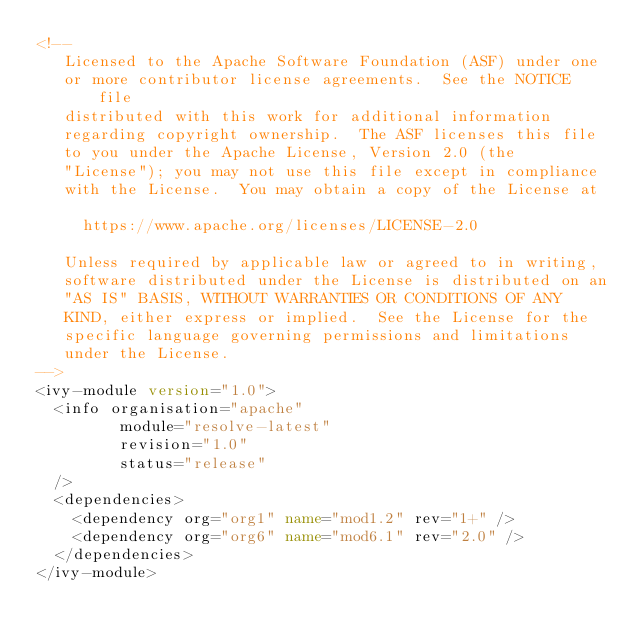Convert code to text. <code><loc_0><loc_0><loc_500><loc_500><_XML_><!--
   Licensed to the Apache Software Foundation (ASF) under one
   or more contributor license agreements.  See the NOTICE file
   distributed with this work for additional information
   regarding copyright ownership.  The ASF licenses this file
   to you under the Apache License, Version 2.0 (the
   "License"); you may not use this file except in compliance
   with the License.  You may obtain a copy of the License at

     https://www.apache.org/licenses/LICENSE-2.0

   Unless required by applicable law or agreed to in writing,
   software distributed under the License is distributed on an
   "AS IS" BASIS, WITHOUT WARRANTIES OR CONDITIONS OF ANY
   KIND, either express or implied.  See the License for the
   specific language governing permissions and limitations
   under the License.    
-->
<ivy-module version="1.0"> 
	<info organisation="apache"
	       module="resolve-latest"
	       revision="1.0"
	       status="release"
	/>
	<dependencies>
		<dependency org="org1" name="mod1.2" rev="1+" />
		<dependency org="org6" name="mod6.1" rev="2.0" />
	</dependencies>
</ivy-module>
</code> 